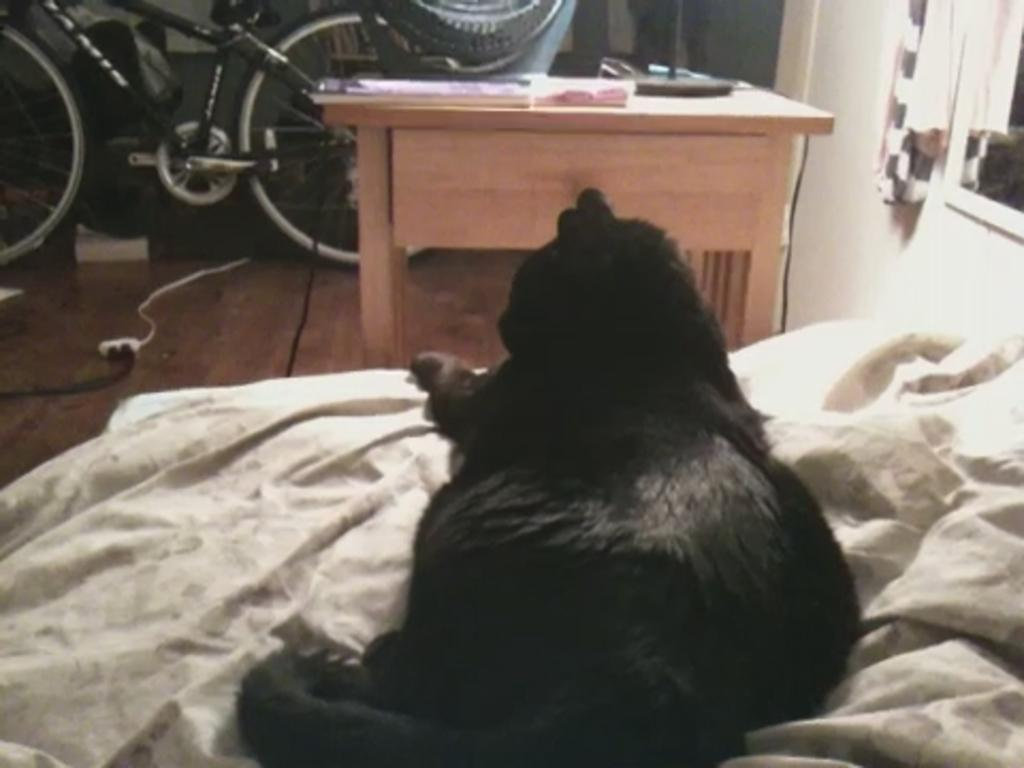What animal can be seen laying on the bed in the image? There is a black cat laying on a bed in the image. What object is in front of the bed? There is a bicycle in front of the bed. What is located in front of the bicycle? There is a table in front of the bicycle. What item can be found on the table? There is a book on the table. What is hanging on the wall in the image? There is a picture on the wall. What type of material is covering the wall? There is cloth on the wall. How many roses are on the ground in the image? There are no roses present in the image; it features a black cat, bicycle, table, book, picture, and cloth on the wall. 